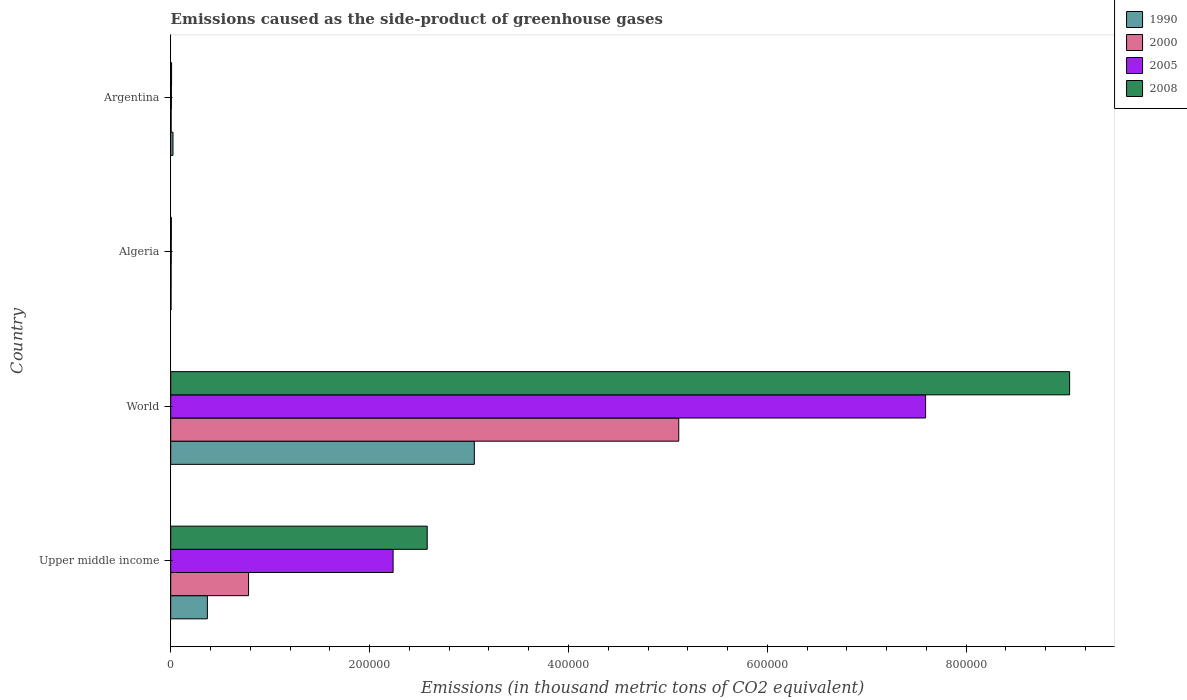How many different coloured bars are there?
Your answer should be compact. 4. Are the number of bars per tick equal to the number of legend labels?
Give a very brief answer. Yes. How many bars are there on the 4th tick from the top?
Offer a terse response. 4. What is the label of the 4th group of bars from the top?
Provide a succinct answer. Upper middle income. What is the emissions caused as the side-product of greenhouse gases in 2000 in Upper middle income?
Your answer should be very brief. 7.83e+04. Across all countries, what is the maximum emissions caused as the side-product of greenhouse gases in 2005?
Your answer should be very brief. 7.59e+05. Across all countries, what is the minimum emissions caused as the side-product of greenhouse gases in 1990?
Provide a short and direct response. 326. In which country was the emissions caused as the side-product of greenhouse gases in 2005 maximum?
Keep it short and to the point. World. In which country was the emissions caused as the side-product of greenhouse gases in 1990 minimum?
Provide a succinct answer. Algeria. What is the total emissions caused as the side-product of greenhouse gases in 2005 in the graph?
Offer a terse response. 9.84e+05. What is the difference between the emissions caused as the side-product of greenhouse gases in 2005 in Algeria and that in Upper middle income?
Ensure brevity in your answer.  -2.23e+05. What is the difference between the emissions caused as the side-product of greenhouse gases in 2005 in Argentina and the emissions caused as the side-product of greenhouse gases in 2000 in World?
Your response must be concise. -5.10e+05. What is the average emissions caused as the side-product of greenhouse gases in 2000 per country?
Make the answer very short. 1.47e+05. What is the difference between the emissions caused as the side-product of greenhouse gases in 1990 and emissions caused as the side-product of greenhouse gases in 2008 in World?
Offer a very short reply. -5.99e+05. What is the ratio of the emissions caused as the side-product of greenhouse gases in 2000 in Algeria to that in Upper middle income?
Keep it short and to the point. 0. What is the difference between the highest and the second highest emissions caused as the side-product of greenhouse gases in 2000?
Offer a terse response. 4.33e+05. What is the difference between the highest and the lowest emissions caused as the side-product of greenhouse gases in 2000?
Offer a terse response. 5.11e+05. In how many countries, is the emissions caused as the side-product of greenhouse gases in 2008 greater than the average emissions caused as the side-product of greenhouse gases in 2008 taken over all countries?
Provide a succinct answer. 1. Is it the case that in every country, the sum of the emissions caused as the side-product of greenhouse gases in 2005 and emissions caused as the side-product of greenhouse gases in 2000 is greater than the sum of emissions caused as the side-product of greenhouse gases in 2008 and emissions caused as the side-product of greenhouse gases in 1990?
Your response must be concise. No. What does the 4th bar from the top in Upper middle income represents?
Offer a terse response. 1990. What does the 4th bar from the bottom in Algeria represents?
Your answer should be compact. 2008. How many bars are there?
Ensure brevity in your answer.  16. Are all the bars in the graph horizontal?
Your response must be concise. Yes. How many countries are there in the graph?
Ensure brevity in your answer.  4. What is the difference between two consecutive major ticks on the X-axis?
Offer a very short reply. 2.00e+05. Does the graph contain any zero values?
Ensure brevity in your answer.  No. Does the graph contain grids?
Provide a short and direct response. No. How are the legend labels stacked?
Your answer should be compact. Vertical. What is the title of the graph?
Your response must be concise. Emissions caused as the side-product of greenhouse gases. What is the label or title of the X-axis?
Provide a short and direct response. Emissions (in thousand metric tons of CO2 equivalent). What is the label or title of the Y-axis?
Your answer should be very brief. Country. What is the Emissions (in thousand metric tons of CO2 equivalent) of 1990 in Upper middle income?
Your answer should be compact. 3.69e+04. What is the Emissions (in thousand metric tons of CO2 equivalent) of 2000 in Upper middle income?
Your answer should be very brief. 7.83e+04. What is the Emissions (in thousand metric tons of CO2 equivalent) of 2005 in Upper middle income?
Offer a very short reply. 2.24e+05. What is the Emissions (in thousand metric tons of CO2 equivalent) of 2008 in Upper middle income?
Offer a very short reply. 2.58e+05. What is the Emissions (in thousand metric tons of CO2 equivalent) of 1990 in World?
Your response must be concise. 3.05e+05. What is the Emissions (in thousand metric tons of CO2 equivalent) of 2000 in World?
Offer a terse response. 5.11e+05. What is the Emissions (in thousand metric tons of CO2 equivalent) of 2005 in World?
Offer a very short reply. 7.59e+05. What is the Emissions (in thousand metric tons of CO2 equivalent) in 2008 in World?
Keep it short and to the point. 9.04e+05. What is the Emissions (in thousand metric tons of CO2 equivalent) in 1990 in Algeria?
Ensure brevity in your answer.  326. What is the Emissions (in thousand metric tons of CO2 equivalent) in 2000 in Algeria?
Ensure brevity in your answer.  371.9. What is the Emissions (in thousand metric tons of CO2 equivalent) of 2005 in Algeria?
Offer a very short reply. 487.4. What is the Emissions (in thousand metric tons of CO2 equivalent) in 2008 in Algeria?
Give a very brief answer. 613.9. What is the Emissions (in thousand metric tons of CO2 equivalent) in 1990 in Argentina?
Offer a very short reply. 2296.5. What is the Emissions (in thousand metric tons of CO2 equivalent) in 2000 in Argentina?
Provide a short and direct response. 408.8. What is the Emissions (in thousand metric tons of CO2 equivalent) in 2005 in Argentina?
Give a very brief answer. 664.9. What is the Emissions (in thousand metric tons of CO2 equivalent) of 2008 in Argentina?
Your answer should be compact. 872.4. Across all countries, what is the maximum Emissions (in thousand metric tons of CO2 equivalent) in 1990?
Make the answer very short. 3.05e+05. Across all countries, what is the maximum Emissions (in thousand metric tons of CO2 equivalent) in 2000?
Offer a very short reply. 5.11e+05. Across all countries, what is the maximum Emissions (in thousand metric tons of CO2 equivalent) of 2005?
Ensure brevity in your answer.  7.59e+05. Across all countries, what is the maximum Emissions (in thousand metric tons of CO2 equivalent) in 2008?
Provide a succinct answer. 9.04e+05. Across all countries, what is the minimum Emissions (in thousand metric tons of CO2 equivalent) in 1990?
Offer a very short reply. 326. Across all countries, what is the minimum Emissions (in thousand metric tons of CO2 equivalent) of 2000?
Your answer should be compact. 371.9. Across all countries, what is the minimum Emissions (in thousand metric tons of CO2 equivalent) of 2005?
Provide a succinct answer. 487.4. Across all countries, what is the minimum Emissions (in thousand metric tons of CO2 equivalent) of 2008?
Offer a terse response. 613.9. What is the total Emissions (in thousand metric tons of CO2 equivalent) in 1990 in the graph?
Keep it short and to the point. 3.45e+05. What is the total Emissions (in thousand metric tons of CO2 equivalent) of 2000 in the graph?
Provide a short and direct response. 5.90e+05. What is the total Emissions (in thousand metric tons of CO2 equivalent) in 2005 in the graph?
Provide a succinct answer. 9.84e+05. What is the total Emissions (in thousand metric tons of CO2 equivalent) of 2008 in the graph?
Ensure brevity in your answer.  1.16e+06. What is the difference between the Emissions (in thousand metric tons of CO2 equivalent) in 1990 in Upper middle income and that in World?
Give a very brief answer. -2.68e+05. What is the difference between the Emissions (in thousand metric tons of CO2 equivalent) of 2000 in Upper middle income and that in World?
Make the answer very short. -4.33e+05. What is the difference between the Emissions (in thousand metric tons of CO2 equivalent) of 2005 in Upper middle income and that in World?
Your response must be concise. -5.36e+05. What is the difference between the Emissions (in thousand metric tons of CO2 equivalent) in 2008 in Upper middle income and that in World?
Your answer should be very brief. -6.46e+05. What is the difference between the Emissions (in thousand metric tons of CO2 equivalent) of 1990 in Upper middle income and that in Algeria?
Ensure brevity in your answer.  3.65e+04. What is the difference between the Emissions (in thousand metric tons of CO2 equivalent) of 2000 in Upper middle income and that in Algeria?
Keep it short and to the point. 7.79e+04. What is the difference between the Emissions (in thousand metric tons of CO2 equivalent) in 2005 in Upper middle income and that in Algeria?
Provide a succinct answer. 2.23e+05. What is the difference between the Emissions (in thousand metric tons of CO2 equivalent) in 2008 in Upper middle income and that in Algeria?
Offer a terse response. 2.57e+05. What is the difference between the Emissions (in thousand metric tons of CO2 equivalent) in 1990 in Upper middle income and that in Argentina?
Offer a very short reply. 3.46e+04. What is the difference between the Emissions (in thousand metric tons of CO2 equivalent) in 2000 in Upper middle income and that in Argentina?
Offer a very short reply. 7.79e+04. What is the difference between the Emissions (in thousand metric tons of CO2 equivalent) in 2005 in Upper middle income and that in Argentina?
Provide a succinct answer. 2.23e+05. What is the difference between the Emissions (in thousand metric tons of CO2 equivalent) of 2008 in Upper middle income and that in Argentina?
Give a very brief answer. 2.57e+05. What is the difference between the Emissions (in thousand metric tons of CO2 equivalent) of 1990 in World and that in Algeria?
Offer a very short reply. 3.05e+05. What is the difference between the Emissions (in thousand metric tons of CO2 equivalent) in 2000 in World and that in Algeria?
Provide a succinct answer. 5.11e+05. What is the difference between the Emissions (in thousand metric tons of CO2 equivalent) of 2005 in World and that in Algeria?
Ensure brevity in your answer.  7.59e+05. What is the difference between the Emissions (in thousand metric tons of CO2 equivalent) of 2008 in World and that in Algeria?
Provide a succinct answer. 9.03e+05. What is the difference between the Emissions (in thousand metric tons of CO2 equivalent) in 1990 in World and that in Argentina?
Your answer should be compact. 3.03e+05. What is the difference between the Emissions (in thousand metric tons of CO2 equivalent) of 2000 in World and that in Argentina?
Keep it short and to the point. 5.10e+05. What is the difference between the Emissions (in thousand metric tons of CO2 equivalent) of 2005 in World and that in Argentina?
Offer a very short reply. 7.58e+05. What is the difference between the Emissions (in thousand metric tons of CO2 equivalent) in 2008 in World and that in Argentina?
Ensure brevity in your answer.  9.03e+05. What is the difference between the Emissions (in thousand metric tons of CO2 equivalent) in 1990 in Algeria and that in Argentina?
Your answer should be compact. -1970.5. What is the difference between the Emissions (in thousand metric tons of CO2 equivalent) of 2000 in Algeria and that in Argentina?
Ensure brevity in your answer.  -36.9. What is the difference between the Emissions (in thousand metric tons of CO2 equivalent) in 2005 in Algeria and that in Argentina?
Provide a succinct answer. -177.5. What is the difference between the Emissions (in thousand metric tons of CO2 equivalent) in 2008 in Algeria and that in Argentina?
Your answer should be compact. -258.5. What is the difference between the Emissions (in thousand metric tons of CO2 equivalent) of 1990 in Upper middle income and the Emissions (in thousand metric tons of CO2 equivalent) of 2000 in World?
Your response must be concise. -4.74e+05. What is the difference between the Emissions (in thousand metric tons of CO2 equivalent) of 1990 in Upper middle income and the Emissions (in thousand metric tons of CO2 equivalent) of 2005 in World?
Give a very brief answer. -7.22e+05. What is the difference between the Emissions (in thousand metric tons of CO2 equivalent) in 1990 in Upper middle income and the Emissions (in thousand metric tons of CO2 equivalent) in 2008 in World?
Offer a terse response. -8.67e+05. What is the difference between the Emissions (in thousand metric tons of CO2 equivalent) in 2000 in Upper middle income and the Emissions (in thousand metric tons of CO2 equivalent) in 2005 in World?
Provide a short and direct response. -6.81e+05. What is the difference between the Emissions (in thousand metric tons of CO2 equivalent) in 2000 in Upper middle income and the Emissions (in thousand metric tons of CO2 equivalent) in 2008 in World?
Your response must be concise. -8.26e+05. What is the difference between the Emissions (in thousand metric tons of CO2 equivalent) in 2005 in Upper middle income and the Emissions (in thousand metric tons of CO2 equivalent) in 2008 in World?
Ensure brevity in your answer.  -6.80e+05. What is the difference between the Emissions (in thousand metric tons of CO2 equivalent) of 1990 in Upper middle income and the Emissions (in thousand metric tons of CO2 equivalent) of 2000 in Algeria?
Your response must be concise. 3.65e+04. What is the difference between the Emissions (in thousand metric tons of CO2 equivalent) in 1990 in Upper middle income and the Emissions (in thousand metric tons of CO2 equivalent) in 2005 in Algeria?
Your answer should be very brief. 3.64e+04. What is the difference between the Emissions (in thousand metric tons of CO2 equivalent) in 1990 in Upper middle income and the Emissions (in thousand metric tons of CO2 equivalent) in 2008 in Algeria?
Offer a terse response. 3.63e+04. What is the difference between the Emissions (in thousand metric tons of CO2 equivalent) in 2000 in Upper middle income and the Emissions (in thousand metric tons of CO2 equivalent) in 2005 in Algeria?
Your response must be concise. 7.78e+04. What is the difference between the Emissions (in thousand metric tons of CO2 equivalent) of 2000 in Upper middle income and the Emissions (in thousand metric tons of CO2 equivalent) of 2008 in Algeria?
Provide a short and direct response. 7.77e+04. What is the difference between the Emissions (in thousand metric tons of CO2 equivalent) in 2005 in Upper middle income and the Emissions (in thousand metric tons of CO2 equivalent) in 2008 in Algeria?
Make the answer very short. 2.23e+05. What is the difference between the Emissions (in thousand metric tons of CO2 equivalent) in 1990 in Upper middle income and the Emissions (in thousand metric tons of CO2 equivalent) in 2000 in Argentina?
Your answer should be compact. 3.65e+04. What is the difference between the Emissions (in thousand metric tons of CO2 equivalent) in 1990 in Upper middle income and the Emissions (in thousand metric tons of CO2 equivalent) in 2005 in Argentina?
Ensure brevity in your answer.  3.62e+04. What is the difference between the Emissions (in thousand metric tons of CO2 equivalent) in 1990 in Upper middle income and the Emissions (in thousand metric tons of CO2 equivalent) in 2008 in Argentina?
Provide a short and direct response. 3.60e+04. What is the difference between the Emissions (in thousand metric tons of CO2 equivalent) of 2000 in Upper middle income and the Emissions (in thousand metric tons of CO2 equivalent) of 2005 in Argentina?
Provide a succinct answer. 7.76e+04. What is the difference between the Emissions (in thousand metric tons of CO2 equivalent) in 2000 in Upper middle income and the Emissions (in thousand metric tons of CO2 equivalent) in 2008 in Argentina?
Make the answer very short. 7.74e+04. What is the difference between the Emissions (in thousand metric tons of CO2 equivalent) in 2005 in Upper middle income and the Emissions (in thousand metric tons of CO2 equivalent) in 2008 in Argentina?
Make the answer very short. 2.23e+05. What is the difference between the Emissions (in thousand metric tons of CO2 equivalent) in 1990 in World and the Emissions (in thousand metric tons of CO2 equivalent) in 2000 in Algeria?
Your answer should be very brief. 3.05e+05. What is the difference between the Emissions (in thousand metric tons of CO2 equivalent) in 1990 in World and the Emissions (in thousand metric tons of CO2 equivalent) in 2005 in Algeria?
Make the answer very short. 3.05e+05. What is the difference between the Emissions (in thousand metric tons of CO2 equivalent) in 1990 in World and the Emissions (in thousand metric tons of CO2 equivalent) in 2008 in Algeria?
Give a very brief answer. 3.05e+05. What is the difference between the Emissions (in thousand metric tons of CO2 equivalent) of 2000 in World and the Emissions (in thousand metric tons of CO2 equivalent) of 2005 in Algeria?
Keep it short and to the point. 5.10e+05. What is the difference between the Emissions (in thousand metric tons of CO2 equivalent) in 2000 in World and the Emissions (in thousand metric tons of CO2 equivalent) in 2008 in Algeria?
Offer a very short reply. 5.10e+05. What is the difference between the Emissions (in thousand metric tons of CO2 equivalent) in 2005 in World and the Emissions (in thousand metric tons of CO2 equivalent) in 2008 in Algeria?
Make the answer very short. 7.59e+05. What is the difference between the Emissions (in thousand metric tons of CO2 equivalent) of 1990 in World and the Emissions (in thousand metric tons of CO2 equivalent) of 2000 in Argentina?
Offer a terse response. 3.05e+05. What is the difference between the Emissions (in thousand metric tons of CO2 equivalent) of 1990 in World and the Emissions (in thousand metric tons of CO2 equivalent) of 2005 in Argentina?
Offer a terse response. 3.05e+05. What is the difference between the Emissions (in thousand metric tons of CO2 equivalent) in 1990 in World and the Emissions (in thousand metric tons of CO2 equivalent) in 2008 in Argentina?
Ensure brevity in your answer.  3.04e+05. What is the difference between the Emissions (in thousand metric tons of CO2 equivalent) of 2000 in World and the Emissions (in thousand metric tons of CO2 equivalent) of 2005 in Argentina?
Offer a terse response. 5.10e+05. What is the difference between the Emissions (in thousand metric tons of CO2 equivalent) in 2000 in World and the Emissions (in thousand metric tons of CO2 equivalent) in 2008 in Argentina?
Make the answer very short. 5.10e+05. What is the difference between the Emissions (in thousand metric tons of CO2 equivalent) in 2005 in World and the Emissions (in thousand metric tons of CO2 equivalent) in 2008 in Argentina?
Give a very brief answer. 7.58e+05. What is the difference between the Emissions (in thousand metric tons of CO2 equivalent) of 1990 in Algeria and the Emissions (in thousand metric tons of CO2 equivalent) of 2000 in Argentina?
Your answer should be compact. -82.8. What is the difference between the Emissions (in thousand metric tons of CO2 equivalent) in 1990 in Algeria and the Emissions (in thousand metric tons of CO2 equivalent) in 2005 in Argentina?
Provide a succinct answer. -338.9. What is the difference between the Emissions (in thousand metric tons of CO2 equivalent) in 1990 in Algeria and the Emissions (in thousand metric tons of CO2 equivalent) in 2008 in Argentina?
Ensure brevity in your answer.  -546.4. What is the difference between the Emissions (in thousand metric tons of CO2 equivalent) of 2000 in Algeria and the Emissions (in thousand metric tons of CO2 equivalent) of 2005 in Argentina?
Your answer should be compact. -293. What is the difference between the Emissions (in thousand metric tons of CO2 equivalent) of 2000 in Algeria and the Emissions (in thousand metric tons of CO2 equivalent) of 2008 in Argentina?
Give a very brief answer. -500.5. What is the difference between the Emissions (in thousand metric tons of CO2 equivalent) of 2005 in Algeria and the Emissions (in thousand metric tons of CO2 equivalent) of 2008 in Argentina?
Your answer should be compact. -385. What is the average Emissions (in thousand metric tons of CO2 equivalent) of 1990 per country?
Give a very brief answer. 8.62e+04. What is the average Emissions (in thousand metric tons of CO2 equivalent) of 2000 per country?
Your answer should be compact. 1.47e+05. What is the average Emissions (in thousand metric tons of CO2 equivalent) of 2005 per country?
Your answer should be very brief. 2.46e+05. What is the average Emissions (in thousand metric tons of CO2 equivalent) in 2008 per country?
Your response must be concise. 2.91e+05. What is the difference between the Emissions (in thousand metric tons of CO2 equivalent) of 1990 and Emissions (in thousand metric tons of CO2 equivalent) of 2000 in Upper middle income?
Make the answer very short. -4.14e+04. What is the difference between the Emissions (in thousand metric tons of CO2 equivalent) in 1990 and Emissions (in thousand metric tons of CO2 equivalent) in 2005 in Upper middle income?
Provide a short and direct response. -1.87e+05. What is the difference between the Emissions (in thousand metric tons of CO2 equivalent) in 1990 and Emissions (in thousand metric tons of CO2 equivalent) in 2008 in Upper middle income?
Provide a succinct answer. -2.21e+05. What is the difference between the Emissions (in thousand metric tons of CO2 equivalent) in 2000 and Emissions (in thousand metric tons of CO2 equivalent) in 2005 in Upper middle income?
Your response must be concise. -1.45e+05. What is the difference between the Emissions (in thousand metric tons of CO2 equivalent) of 2000 and Emissions (in thousand metric tons of CO2 equivalent) of 2008 in Upper middle income?
Your response must be concise. -1.80e+05. What is the difference between the Emissions (in thousand metric tons of CO2 equivalent) in 2005 and Emissions (in thousand metric tons of CO2 equivalent) in 2008 in Upper middle income?
Your answer should be very brief. -3.43e+04. What is the difference between the Emissions (in thousand metric tons of CO2 equivalent) in 1990 and Emissions (in thousand metric tons of CO2 equivalent) in 2000 in World?
Your response must be concise. -2.06e+05. What is the difference between the Emissions (in thousand metric tons of CO2 equivalent) of 1990 and Emissions (in thousand metric tons of CO2 equivalent) of 2005 in World?
Your answer should be compact. -4.54e+05. What is the difference between the Emissions (in thousand metric tons of CO2 equivalent) in 1990 and Emissions (in thousand metric tons of CO2 equivalent) in 2008 in World?
Give a very brief answer. -5.99e+05. What is the difference between the Emissions (in thousand metric tons of CO2 equivalent) of 2000 and Emissions (in thousand metric tons of CO2 equivalent) of 2005 in World?
Keep it short and to the point. -2.48e+05. What is the difference between the Emissions (in thousand metric tons of CO2 equivalent) in 2000 and Emissions (in thousand metric tons of CO2 equivalent) in 2008 in World?
Keep it short and to the point. -3.93e+05. What is the difference between the Emissions (in thousand metric tons of CO2 equivalent) of 2005 and Emissions (in thousand metric tons of CO2 equivalent) of 2008 in World?
Keep it short and to the point. -1.45e+05. What is the difference between the Emissions (in thousand metric tons of CO2 equivalent) in 1990 and Emissions (in thousand metric tons of CO2 equivalent) in 2000 in Algeria?
Offer a very short reply. -45.9. What is the difference between the Emissions (in thousand metric tons of CO2 equivalent) of 1990 and Emissions (in thousand metric tons of CO2 equivalent) of 2005 in Algeria?
Keep it short and to the point. -161.4. What is the difference between the Emissions (in thousand metric tons of CO2 equivalent) in 1990 and Emissions (in thousand metric tons of CO2 equivalent) in 2008 in Algeria?
Ensure brevity in your answer.  -287.9. What is the difference between the Emissions (in thousand metric tons of CO2 equivalent) in 2000 and Emissions (in thousand metric tons of CO2 equivalent) in 2005 in Algeria?
Ensure brevity in your answer.  -115.5. What is the difference between the Emissions (in thousand metric tons of CO2 equivalent) in 2000 and Emissions (in thousand metric tons of CO2 equivalent) in 2008 in Algeria?
Your answer should be compact. -242. What is the difference between the Emissions (in thousand metric tons of CO2 equivalent) of 2005 and Emissions (in thousand metric tons of CO2 equivalent) of 2008 in Algeria?
Make the answer very short. -126.5. What is the difference between the Emissions (in thousand metric tons of CO2 equivalent) in 1990 and Emissions (in thousand metric tons of CO2 equivalent) in 2000 in Argentina?
Provide a succinct answer. 1887.7. What is the difference between the Emissions (in thousand metric tons of CO2 equivalent) in 1990 and Emissions (in thousand metric tons of CO2 equivalent) in 2005 in Argentina?
Offer a terse response. 1631.6. What is the difference between the Emissions (in thousand metric tons of CO2 equivalent) of 1990 and Emissions (in thousand metric tons of CO2 equivalent) of 2008 in Argentina?
Keep it short and to the point. 1424.1. What is the difference between the Emissions (in thousand metric tons of CO2 equivalent) of 2000 and Emissions (in thousand metric tons of CO2 equivalent) of 2005 in Argentina?
Your response must be concise. -256.1. What is the difference between the Emissions (in thousand metric tons of CO2 equivalent) of 2000 and Emissions (in thousand metric tons of CO2 equivalent) of 2008 in Argentina?
Keep it short and to the point. -463.6. What is the difference between the Emissions (in thousand metric tons of CO2 equivalent) of 2005 and Emissions (in thousand metric tons of CO2 equivalent) of 2008 in Argentina?
Provide a short and direct response. -207.5. What is the ratio of the Emissions (in thousand metric tons of CO2 equivalent) of 1990 in Upper middle income to that in World?
Make the answer very short. 0.12. What is the ratio of the Emissions (in thousand metric tons of CO2 equivalent) in 2000 in Upper middle income to that in World?
Offer a terse response. 0.15. What is the ratio of the Emissions (in thousand metric tons of CO2 equivalent) of 2005 in Upper middle income to that in World?
Make the answer very short. 0.29. What is the ratio of the Emissions (in thousand metric tons of CO2 equivalent) of 2008 in Upper middle income to that in World?
Ensure brevity in your answer.  0.29. What is the ratio of the Emissions (in thousand metric tons of CO2 equivalent) in 1990 in Upper middle income to that in Algeria?
Your response must be concise. 113.09. What is the ratio of the Emissions (in thousand metric tons of CO2 equivalent) of 2000 in Upper middle income to that in Algeria?
Your answer should be compact. 210.49. What is the ratio of the Emissions (in thousand metric tons of CO2 equivalent) of 2005 in Upper middle income to that in Algeria?
Ensure brevity in your answer.  458.83. What is the ratio of the Emissions (in thousand metric tons of CO2 equivalent) in 2008 in Upper middle income to that in Algeria?
Offer a very short reply. 420.19. What is the ratio of the Emissions (in thousand metric tons of CO2 equivalent) of 1990 in Upper middle income to that in Argentina?
Make the answer very short. 16.05. What is the ratio of the Emissions (in thousand metric tons of CO2 equivalent) in 2000 in Upper middle income to that in Argentina?
Provide a short and direct response. 191.49. What is the ratio of the Emissions (in thousand metric tons of CO2 equivalent) of 2005 in Upper middle income to that in Argentina?
Your response must be concise. 336.34. What is the ratio of the Emissions (in thousand metric tons of CO2 equivalent) of 2008 in Upper middle income to that in Argentina?
Your answer should be very brief. 295.68. What is the ratio of the Emissions (in thousand metric tons of CO2 equivalent) in 1990 in World to that in Algeria?
Ensure brevity in your answer.  936.6. What is the ratio of the Emissions (in thousand metric tons of CO2 equivalent) in 2000 in World to that in Algeria?
Your answer should be very brief. 1373.76. What is the ratio of the Emissions (in thousand metric tons of CO2 equivalent) in 2005 in World to that in Algeria?
Offer a very short reply. 1557.54. What is the ratio of the Emissions (in thousand metric tons of CO2 equivalent) in 2008 in World to that in Algeria?
Ensure brevity in your answer.  1472.53. What is the ratio of the Emissions (in thousand metric tons of CO2 equivalent) of 1990 in World to that in Argentina?
Your answer should be very brief. 132.95. What is the ratio of the Emissions (in thousand metric tons of CO2 equivalent) in 2000 in World to that in Argentina?
Provide a succinct answer. 1249.76. What is the ratio of the Emissions (in thousand metric tons of CO2 equivalent) of 2005 in World to that in Argentina?
Your response must be concise. 1141.74. What is the ratio of the Emissions (in thousand metric tons of CO2 equivalent) in 2008 in World to that in Argentina?
Keep it short and to the point. 1036.2. What is the ratio of the Emissions (in thousand metric tons of CO2 equivalent) in 1990 in Algeria to that in Argentina?
Provide a succinct answer. 0.14. What is the ratio of the Emissions (in thousand metric tons of CO2 equivalent) of 2000 in Algeria to that in Argentina?
Provide a short and direct response. 0.91. What is the ratio of the Emissions (in thousand metric tons of CO2 equivalent) of 2005 in Algeria to that in Argentina?
Offer a terse response. 0.73. What is the ratio of the Emissions (in thousand metric tons of CO2 equivalent) in 2008 in Algeria to that in Argentina?
Your response must be concise. 0.7. What is the difference between the highest and the second highest Emissions (in thousand metric tons of CO2 equivalent) of 1990?
Ensure brevity in your answer.  2.68e+05. What is the difference between the highest and the second highest Emissions (in thousand metric tons of CO2 equivalent) of 2000?
Give a very brief answer. 4.33e+05. What is the difference between the highest and the second highest Emissions (in thousand metric tons of CO2 equivalent) of 2005?
Give a very brief answer. 5.36e+05. What is the difference between the highest and the second highest Emissions (in thousand metric tons of CO2 equivalent) of 2008?
Keep it short and to the point. 6.46e+05. What is the difference between the highest and the lowest Emissions (in thousand metric tons of CO2 equivalent) in 1990?
Offer a very short reply. 3.05e+05. What is the difference between the highest and the lowest Emissions (in thousand metric tons of CO2 equivalent) of 2000?
Provide a succinct answer. 5.11e+05. What is the difference between the highest and the lowest Emissions (in thousand metric tons of CO2 equivalent) of 2005?
Provide a succinct answer. 7.59e+05. What is the difference between the highest and the lowest Emissions (in thousand metric tons of CO2 equivalent) in 2008?
Your answer should be compact. 9.03e+05. 